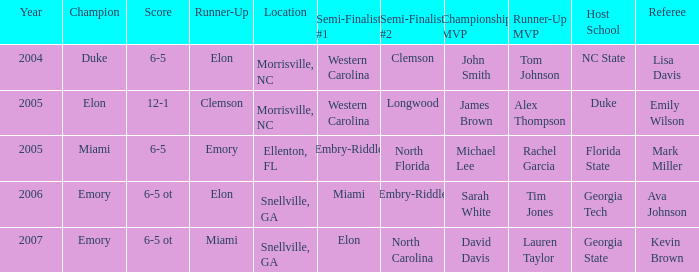Enumerate the scores of every game when miami was positioned as the initial semi-finalist. 6-5 ot. 